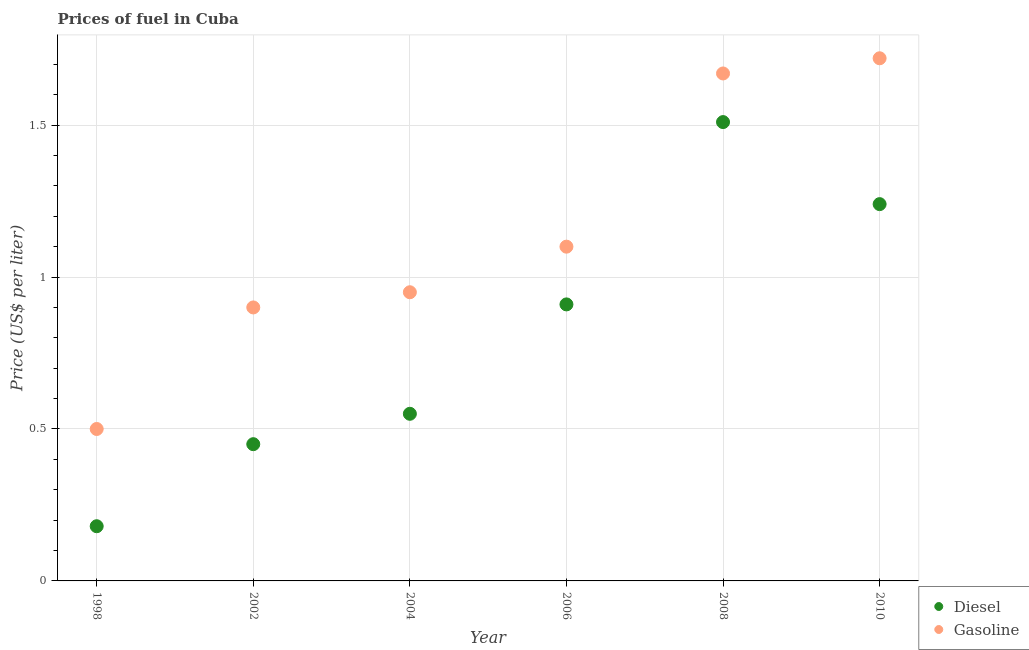What is the gasoline price in 2010?
Keep it short and to the point. 1.72. Across all years, what is the maximum diesel price?
Provide a succinct answer. 1.51. Across all years, what is the minimum diesel price?
Provide a succinct answer. 0.18. In which year was the diesel price minimum?
Offer a terse response. 1998. What is the total gasoline price in the graph?
Your response must be concise. 6.84. What is the difference between the gasoline price in 2002 and that in 2004?
Provide a short and direct response. -0.05. What is the average diesel price per year?
Your response must be concise. 0.81. In the year 2004, what is the difference between the diesel price and gasoline price?
Keep it short and to the point. -0.4. What is the ratio of the gasoline price in 2004 to that in 2010?
Make the answer very short. 0.55. What is the difference between the highest and the second highest diesel price?
Your answer should be very brief. 0.27. What is the difference between the highest and the lowest diesel price?
Keep it short and to the point. 1.33. In how many years, is the gasoline price greater than the average gasoline price taken over all years?
Ensure brevity in your answer.  2. Is the sum of the gasoline price in 1998 and 2004 greater than the maximum diesel price across all years?
Ensure brevity in your answer.  No. Does the diesel price monotonically increase over the years?
Make the answer very short. No. How many dotlines are there?
Your response must be concise. 2. What is the difference between two consecutive major ticks on the Y-axis?
Ensure brevity in your answer.  0.5. Are the values on the major ticks of Y-axis written in scientific E-notation?
Provide a short and direct response. No. Does the graph contain any zero values?
Give a very brief answer. No. Does the graph contain grids?
Make the answer very short. Yes. Where does the legend appear in the graph?
Provide a short and direct response. Bottom right. How many legend labels are there?
Give a very brief answer. 2. What is the title of the graph?
Your answer should be compact. Prices of fuel in Cuba. Does "Forest land" appear as one of the legend labels in the graph?
Your answer should be compact. No. What is the label or title of the Y-axis?
Ensure brevity in your answer.  Price (US$ per liter). What is the Price (US$ per liter) of Diesel in 1998?
Your answer should be very brief. 0.18. What is the Price (US$ per liter) in Diesel in 2002?
Provide a succinct answer. 0.45. What is the Price (US$ per liter) in Diesel in 2004?
Keep it short and to the point. 0.55. What is the Price (US$ per liter) of Diesel in 2006?
Your answer should be very brief. 0.91. What is the Price (US$ per liter) in Diesel in 2008?
Provide a short and direct response. 1.51. What is the Price (US$ per liter) in Gasoline in 2008?
Keep it short and to the point. 1.67. What is the Price (US$ per liter) in Diesel in 2010?
Provide a short and direct response. 1.24. What is the Price (US$ per liter) of Gasoline in 2010?
Your response must be concise. 1.72. Across all years, what is the maximum Price (US$ per liter) of Diesel?
Keep it short and to the point. 1.51. Across all years, what is the maximum Price (US$ per liter) of Gasoline?
Offer a very short reply. 1.72. Across all years, what is the minimum Price (US$ per liter) of Diesel?
Offer a very short reply. 0.18. Across all years, what is the minimum Price (US$ per liter) of Gasoline?
Offer a terse response. 0.5. What is the total Price (US$ per liter) in Diesel in the graph?
Your response must be concise. 4.84. What is the total Price (US$ per liter) in Gasoline in the graph?
Your response must be concise. 6.84. What is the difference between the Price (US$ per liter) in Diesel in 1998 and that in 2002?
Make the answer very short. -0.27. What is the difference between the Price (US$ per liter) in Gasoline in 1998 and that in 2002?
Ensure brevity in your answer.  -0.4. What is the difference between the Price (US$ per liter) in Diesel in 1998 and that in 2004?
Give a very brief answer. -0.37. What is the difference between the Price (US$ per liter) in Gasoline in 1998 and that in 2004?
Offer a very short reply. -0.45. What is the difference between the Price (US$ per liter) in Diesel in 1998 and that in 2006?
Keep it short and to the point. -0.73. What is the difference between the Price (US$ per liter) of Gasoline in 1998 and that in 2006?
Make the answer very short. -0.6. What is the difference between the Price (US$ per liter) of Diesel in 1998 and that in 2008?
Offer a terse response. -1.33. What is the difference between the Price (US$ per liter) of Gasoline in 1998 and that in 2008?
Your answer should be compact. -1.17. What is the difference between the Price (US$ per liter) of Diesel in 1998 and that in 2010?
Keep it short and to the point. -1.06. What is the difference between the Price (US$ per liter) of Gasoline in 1998 and that in 2010?
Your answer should be compact. -1.22. What is the difference between the Price (US$ per liter) of Gasoline in 2002 and that in 2004?
Your answer should be compact. -0.05. What is the difference between the Price (US$ per liter) in Diesel in 2002 and that in 2006?
Make the answer very short. -0.46. What is the difference between the Price (US$ per liter) of Diesel in 2002 and that in 2008?
Provide a short and direct response. -1.06. What is the difference between the Price (US$ per liter) of Gasoline in 2002 and that in 2008?
Offer a very short reply. -0.77. What is the difference between the Price (US$ per liter) of Diesel in 2002 and that in 2010?
Your answer should be very brief. -0.79. What is the difference between the Price (US$ per liter) in Gasoline in 2002 and that in 2010?
Your answer should be compact. -0.82. What is the difference between the Price (US$ per liter) in Diesel in 2004 and that in 2006?
Your answer should be compact. -0.36. What is the difference between the Price (US$ per liter) in Diesel in 2004 and that in 2008?
Your answer should be compact. -0.96. What is the difference between the Price (US$ per liter) of Gasoline in 2004 and that in 2008?
Offer a very short reply. -0.72. What is the difference between the Price (US$ per liter) in Diesel in 2004 and that in 2010?
Give a very brief answer. -0.69. What is the difference between the Price (US$ per liter) in Gasoline in 2004 and that in 2010?
Offer a terse response. -0.77. What is the difference between the Price (US$ per liter) in Diesel in 2006 and that in 2008?
Your answer should be very brief. -0.6. What is the difference between the Price (US$ per liter) in Gasoline in 2006 and that in 2008?
Your response must be concise. -0.57. What is the difference between the Price (US$ per liter) in Diesel in 2006 and that in 2010?
Your answer should be very brief. -0.33. What is the difference between the Price (US$ per liter) of Gasoline in 2006 and that in 2010?
Provide a succinct answer. -0.62. What is the difference between the Price (US$ per liter) in Diesel in 2008 and that in 2010?
Your response must be concise. 0.27. What is the difference between the Price (US$ per liter) of Diesel in 1998 and the Price (US$ per liter) of Gasoline in 2002?
Make the answer very short. -0.72. What is the difference between the Price (US$ per liter) of Diesel in 1998 and the Price (US$ per liter) of Gasoline in 2004?
Offer a terse response. -0.77. What is the difference between the Price (US$ per liter) of Diesel in 1998 and the Price (US$ per liter) of Gasoline in 2006?
Provide a short and direct response. -0.92. What is the difference between the Price (US$ per liter) of Diesel in 1998 and the Price (US$ per liter) of Gasoline in 2008?
Your answer should be very brief. -1.49. What is the difference between the Price (US$ per liter) of Diesel in 1998 and the Price (US$ per liter) of Gasoline in 2010?
Your response must be concise. -1.54. What is the difference between the Price (US$ per liter) of Diesel in 2002 and the Price (US$ per liter) of Gasoline in 2006?
Keep it short and to the point. -0.65. What is the difference between the Price (US$ per liter) in Diesel in 2002 and the Price (US$ per liter) in Gasoline in 2008?
Make the answer very short. -1.22. What is the difference between the Price (US$ per liter) of Diesel in 2002 and the Price (US$ per liter) of Gasoline in 2010?
Offer a very short reply. -1.27. What is the difference between the Price (US$ per liter) in Diesel in 2004 and the Price (US$ per liter) in Gasoline in 2006?
Keep it short and to the point. -0.55. What is the difference between the Price (US$ per liter) in Diesel in 2004 and the Price (US$ per liter) in Gasoline in 2008?
Offer a very short reply. -1.12. What is the difference between the Price (US$ per liter) of Diesel in 2004 and the Price (US$ per liter) of Gasoline in 2010?
Your response must be concise. -1.17. What is the difference between the Price (US$ per liter) of Diesel in 2006 and the Price (US$ per liter) of Gasoline in 2008?
Give a very brief answer. -0.76. What is the difference between the Price (US$ per liter) of Diesel in 2006 and the Price (US$ per liter) of Gasoline in 2010?
Make the answer very short. -0.81. What is the difference between the Price (US$ per liter) of Diesel in 2008 and the Price (US$ per liter) of Gasoline in 2010?
Offer a terse response. -0.21. What is the average Price (US$ per liter) of Diesel per year?
Ensure brevity in your answer.  0.81. What is the average Price (US$ per liter) in Gasoline per year?
Your answer should be compact. 1.14. In the year 1998, what is the difference between the Price (US$ per liter) in Diesel and Price (US$ per liter) in Gasoline?
Keep it short and to the point. -0.32. In the year 2002, what is the difference between the Price (US$ per liter) in Diesel and Price (US$ per liter) in Gasoline?
Ensure brevity in your answer.  -0.45. In the year 2006, what is the difference between the Price (US$ per liter) of Diesel and Price (US$ per liter) of Gasoline?
Your answer should be very brief. -0.19. In the year 2008, what is the difference between the Price (US$ per liter) in Diesel and Price (US$ per liter) in Gasoline?
Provide a short and direct response. -0.16. In the year 2010, what is the difference between the Price (US$ per liter) in Diesel and Price (US$ per liter) in Gasoline?
Make the answer very short. -0.48. What is the ratio of the Price (US$ per liter) in Gasoline in 1998 to that in 2002?
Offer a terse response. 0.56. What is the ratio of the Price (US$ per liter) in Diesel in 1998 to that in 2004?
Your answer should be very brief. 0.33. What is the ratio of the Price (US$ per liter) in Gasoline in 1998 to that in 2004?
Your answer should be compact. 0.53. What is the ratio of the Price (US$ per liter) in Diesel in 1998 to that in 2006?
Your answer should be very brief. 0.2. What is the ratio of the Price (US$ per liter) in Gasoline in 1998 to that in 2006?
Give a very brief answer. 0.45. What is the ratio of the Price (US$ per liter) in Diesel in 1998 to that in 2008?
Keep it short and to the point. 0.12. What is the ratio of the Price (US$ per liter) in Gasoline in 1998 to that in 2008?
Your response must be concise. 0.3. What is the ratio of the Price (US$ per liter) in Diesel in 1998 to that in 2010?
Your answer should be compact. 0.15. What is the ratio of the Price (US$ per liter) of Gasoline in 1998 to that in 2010?
Provide a short and direct response. 0.29. What is the ratio of the Price (US$ per liter) of Diesel in 2002 to that in 2004?
Offer a very short reply. 0.82. What is the ratio of the Price (US$ per liter) in Gasoline in 2002 to that in 2004?
Provide a succinct answer. 0.95. What is the ratio of the Price (US$ per liter) of Diesel in 2002 to that in 2006?
Your response must be concise. 0.49. What is the ratio of the Price (US$ per liter) in Gasoline in 2002 to that in 2006?
Your answer should be very brief. 0.82. What is the ratio of the Price (US$ per liter) in Diesel in 2002 to that in 2008?
Provide a short and direct response. 0.3. What is the ratio of the Price (US$ per liter) in Gasoline in 2002 to that in 2008?
Keep it short and to the point. 0.54. What is the ratio of the Price (US$ per liter) of Diesel in 2002 to that in 2010?
Offer a very short reply. 0.36. What is the ratio of the Price (US$ per liter) in Gasoline in 2002 to that in 2010?
Make the answer very short. 0.52. What is the ratio of the Price (US$ per liter) in Diesel in 2004 to that in 2006?
Your response must be concise. 0.6. What is the ratio of the Price (US$ per liter) in Gasoline in 2004 to that in 2006?
Ensure brevity in your answer.  0.86. What is the ratio of the Price (US$ per liter) in Diesel in 2004 to that in 2008?
Ensure brevity in your answer.  0.36. What is the ratio of the Price (US$ per liter) of Gasoline in 2004 to that in 2008?
Provide a short and direct response. 0.57. What is the ratio of the Price (US$ per liter) in Diesel in 2004 to that in 2010?
Ensure brevity in your answer.  0.44. What is the ratio of the Price (US$ per liter) in Gasoline in 2004 to that in 2010?
Your answer should be very brief. 0.55. What is the ratio of the Price (US$ per liter) of Diesel in 2006 to that in 2008?
Provide a short and direct response. 0.6. What is the ratio of the Price (US$ per liter) of Gasoline in 2006 to that in 2008?
Give a very brief answer. 0.66. What is the ratio of the Price (US$ per liter) in Diesel in 2006 to that in 2010?
Your answer should be very brief. 0.73. What is the ratio of the Price (US$ per liter) in Gasoline in 2006 to that in 2010?
Offer a very short reply. 0.64. What is the ratio of the Price (US$ per liter) in Diesel in 2008 to that in 2010?
Your answer should be compact. 1.22. What is the ratio of the Price (US$ per liter) of Gasoline in 2008 to that in 2010?
Ensure brevity in your answer.  0.97. What is the difference between the highest and the second highest Price (US$ per liter) in Diesel?
Offer a terse response. 0.27. What is the difference between the highest and the second highest Price (US$ per liter) of Gasoline?
Your response must be concise. 0.05. What is the difference between the highest and the lowest Price (US$ per liter) of Diesel?
Your answer should be compact. 1.33. What is the difference between the highest and the lowest Price (US$ per liter) of Gasoline?
Keep it short and to the point. 1.22. 